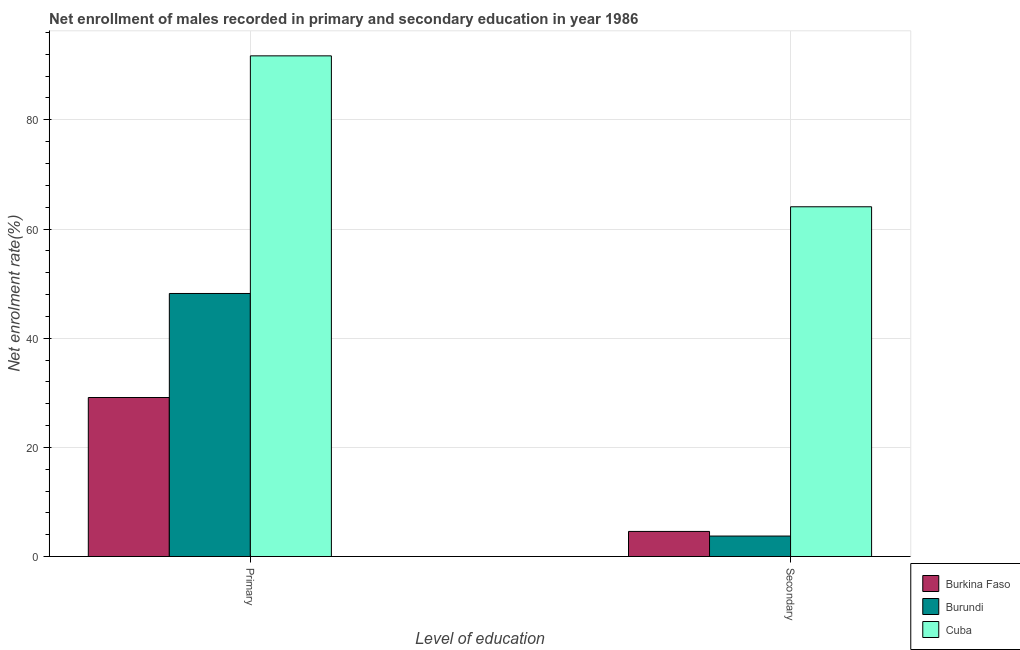How many different coloured bars are there?
Ensure brevity in your answer.  3. How many groups of bars are there?
Make the answer very short. 2. Are the number of bars per tick equal to the number of legend labels?
Your answer should be compact. Yes. Are the number of bars on each tick of the X-axis equal?
Provide a short and direct response. Yes. How many bars are there on the 1st tick from the right?
Offer a very short reply. 3. What is the label of the 2nd group of bars from the left?
Make the answer very short. Secondary. What is the enrollment rate in primary education in Cuba?
Your response must be concise. 91.72. Across all countries, what is the maximum enrollment rate in secondary education?
Your answer should be very brief. 64.07. Across all countries, what is the minimum enrollment rate in primary education?
Offer a terse response. 29.13. In which country was the enrollment rate in primary education maximum?
Your response must be concise. Cuba. In which country was the enrollment rate in secondary education minimum?
Your answer should be compact. Burundi. What is the total enrollment rate in primary education in the graph?
Offer a very short reply. 169.04. What is the difference between the enrollment rate in secondary education in Burkina Faso and that in Burundi?
Ensure brevity in your answer.  0.85. What is the difference between the enrollment rate in primary education in Burkina Faso and the enrollment rate in secondary education in Burundi?
Your response must be concise. 25.38. What is the average enrollment rate in primary education per country?
Keep it short and to the point. 56.35. What is the difference between the enrollment rate in primary education and enrollment rate in secondary education in Burundi?
Provide a succinct answer. 44.44. In how many countries, is the enrollment rate in primary education greater than 80 %?
Your response must be concise. 1. What is the ratio of the enrollment rate in secondary education in Burundi to that in Cuba?
Provide a short and direct response. 0.06. Is the enrollment rate in primary education in Cuba less than that in Burkina Faso?
Provide a succinct answer. No. What does the 2nd bar from the left in Secondary represents?
Offer a very short reply. Burundi. What does the 3rd bar from the right in Secondary represents?
Offer a very short reply. Burkina Faso. Are all the bars in the graph horizontal?
Keep it short and to the point. No. Are the values on the major ticks of Y-axis written in scientific E-notation?
Give a very brief answer. No. What is the title of the graph?
Offer a very short reply. Net enrollment of males recorded in primary and secondary education in year 1986. Does "New Zealand" appear as one of the legend labels in the graph?
Provide a short and direct response. No. What is the label or title of the X-axis?
Offer a very short reply. Level of education. What is the label or title of the Y-axis?
Ensure brevity in your answer.  Net enrolment rate(%). What is the Net enrolment rate(%) in Burkina Faso in Primary?
Offer a very short reply. 29.13. What is the Net enrolment rate(%) of Burundi in Primary?
Keep it short and to the point. 48.19. What is the Net enrolment rate(%) of Cuba in Primary?
Keep it short and to the point. 91.72. What is the Net enrolment rate(%) in Burkina Faso in Secondary?
Your response must be concise. 4.6. What is the Net enrolment rate(%) in Burundi in Secondary?
Ensure brevity in your answer.  3.75. What is the Net enrolment rate(%) of Cuba in Secondary?
Make the answer very short. 64.07. Across all Level of education, what is the maximum Net enrolment rate(%) in Burkina Faso?
Make the answer very short. 29.13. Across all Level of education, what is the maximum Net enrolment rate(%) in Burundi?
Make the answer very short. 48.19. Across all Level of education, what is the maximum Net enrolment rate(%) in Cuba?
Ensure brevity in your answer.  91.72. Across all Level of education, what is the minimum Net enrolment rate(%) of Burkina Faso?
Your answer should be very brief. 4.6. Across all Level of education, what is the minimum Net enrolment rate(%) of Burundi?
Give a very brief answer. 3.75. Across all Level of education, what is the minimum Net enrolment rate(%) of Cuba?
Keep it short and to the point. 64.07. What is the total Net enrolment rate(%) of Burkina Faso in the graph?
Provide a short and direct response. 33.73. What is the total Net enrolment rate(%) in Burundi in the graph?
Your answer should be very brief. 51.94. What is the total Net enrolment rate(%) of Cuba in the graph?
Provide a short and direct response. 155.79. What is the difference between the Net enrolment rate(%) of Burkina Faso in Primary and that in Secondary?
Offer a very short reply. 24.53. What is the difference between the Net enrolment rate(%) in Burundi in Primary and that in Secondary?
Give a very brief answer. 44.44. What is the difference between the Net enrolment rate(%) in Cuba in Primary and that in Secondary?
Provide a short and direct response. 27.65. What is the difference between the Net enrolment rate(%) in Burkina Faso in Primary and the Net enrolment rate(%) in Burundi in Secondary?
Provide a short and direct response. 25.38. What is the difference between the Net enrolment rate(%) in Burkina Faso in Primary and the Net enrolment rate(%) in Cuba in Secondary?
Give a very brief answer. -34.94. What is the difference between the Net enrolment rate(%) in Burundi in Primary and the Net enrolment rate(%) in Cuba in Secondary?
Provide a succinct answer. -15.88. What is the average Net enrolment rate(%) in Burkina Faso per Level of education?
Provide a short and direct response. 16.86. What is the average Net enrolment rate(%) in Burundi per Level of education?
Your response must be concise. 25.97. What is the average Net enrolment rate(%) of Cuba per Level of education?
Offer a terse response. 77.9. What is the difference between the Net enrolment rate(%) of Burkina Faso and Net enrolment rate(%) of Burundi in Primary?
Keep it short and to the point. -19.06. What is the difference between the Net enrolment rate(%) of Burkina Faso and Net enrolment rate(%) of Cuba in Primary?
Provide a short and direct response. -62.59. What is the difference between the Net enrolment rate(%) of Burundi and Net enrolment rate(%) of Cuba in Primary?
Your answer should be very brief. -43.53. What is the difference between the Net enrolment rate(%) in Burkina Faso and Net enrolment rate(%) in Burundi in Secondary?
Provide a short and direct response. 0.85. What is the difference between the Net enrolment rate(%) of Burkina Faso and Net enrolment rate(%) of Cuba in Secondary?
Your response must be concise. -59.47. What is the difference between the Net enrolment rate(%) in Burundi and Net enrolment rate(%) in Cuba in Secondary?
Your response must be concise. -60.32. What is the ratio of the Net enrolment rate(%) in Burkina Faso in Primary to that in Secondary?
Provide a short and direct response. 6.34. What is the ratio of the Net enrolment rate(%) in Burundi in Primary to that in Secondary?
Provide a succinct answer. 12.85. What is the ratio of the Net enrolment rate(%) of Cuba in Primary to that in Secondary?
Your response must be concise. 1.43. What is the difference between the highest and the second highest Net enrolment rate(%) in Burkina Faso?
Your answer should be compact. 24.53. What is the difference between the highest and the second highest Net enrolment rate(%) of Burundi?
Make the answer very short. 44.44. What is the difference between the highest and the second highest Net enrolment rate(%) in Cuba?
Provide a succinct answer. 27.65. What is the difference between the highest and the lowest Net enrolment rate(%) of Burkina Faso?
Your answer should be compact. 24.53. What is the difference between the highest and the lowest Net enrolment rate(%) of Burundi?
Your answer should be very brief. 44.44. What is the difference between the highest and the lowest Net enrolment rate(%) of Cuba?
Ensure brevity in your answer.  27.65. 